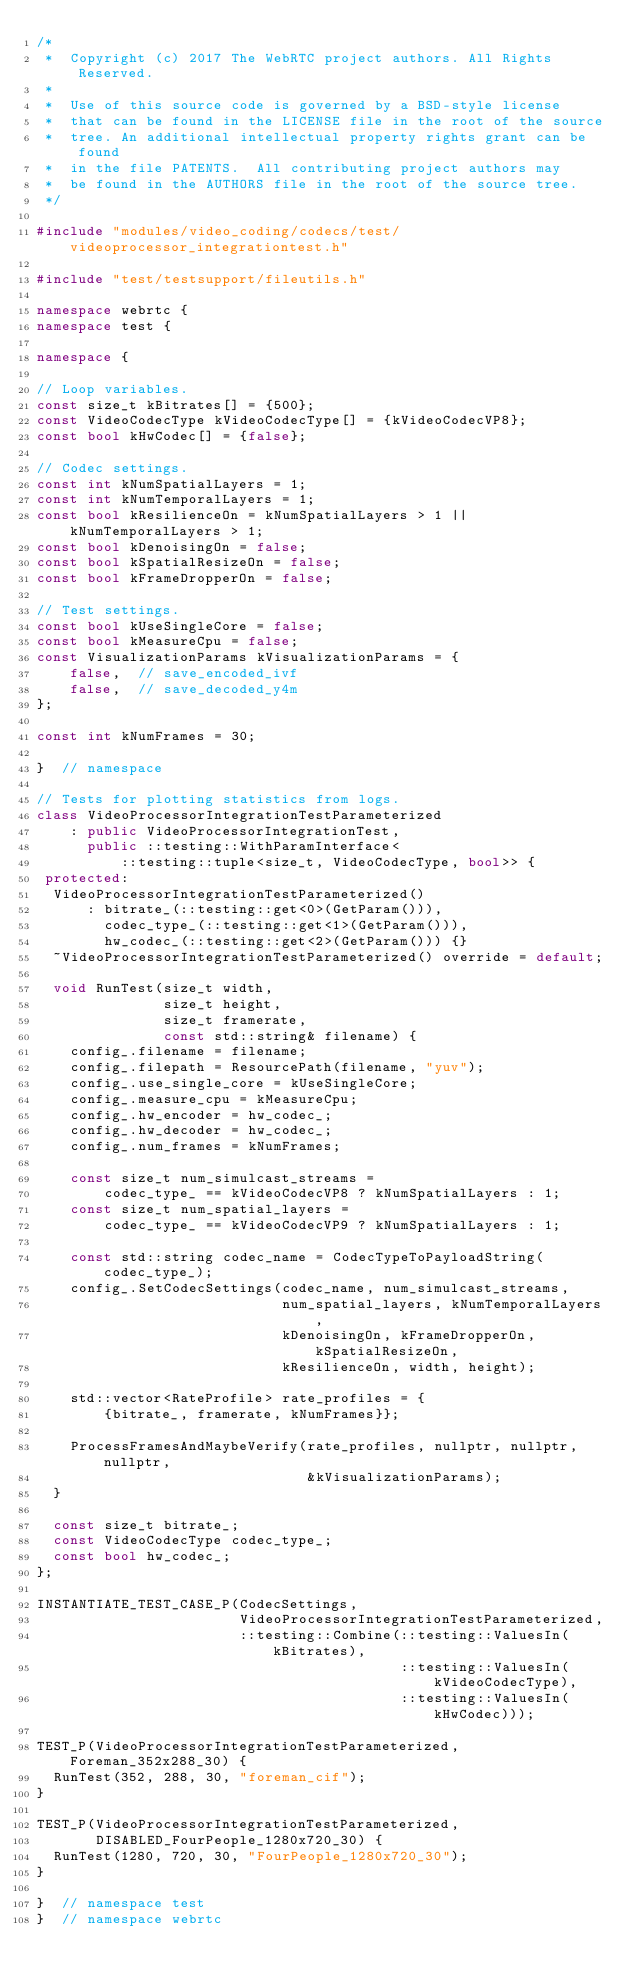<code> <loc_0><loc_0><loc_500><loc_500><_C++_>/*
 *  Copyright (c) 2017 The WebRTC project authors. All Rights Reserved.
 *
 *  Use of this source code is governed by a BSD-style license
 *  that can be found in the LICENSE file in the root of the source
 *  tree. An additional intellectual property rights grant can be found
 *  in the file PATENTS.  All contributing project authors may
 *  be found in the AUTHORS file in the root of the source tree.
 */

#include "modules/video_coding/codecs/test/videoprocessor_integrationtest.h"

#include "test/testsupport/fileutils.h"

namespace webrtc {
namespace test {

namespace {

// Loop variables.
const size_t kBitrates[] = {500};
const VideoCodecType kVideoCodecType[] = {kVideoCodecVP8};
const bool kHwCodec[] = {false};

// Codec settings.
const int kNumSpatialLayers = 1;
const int kNumTemporalLayers = 1;
const bool kResilienceOn = kNumSpatialLayers > 1 || kNumTemporalLayers > 1;
const bool kDenoisingOn = false;
const bool kSpatialResizeOn = false;
const bool kFrameDropperOn = false;

// Test settings.
const bool kUseSingleCore = false;
const bool kMeasureCpu = false;
const VisualizationParams kVisualizationParams = {
    false,  // save_encoded_ivf
    false,  // save_decoded_y4m
};

const int kNumFrames = 30;

}  // namespace

// Tests for plotting statistics from logs.
class VideoProcessorIntegrationTestParameterized
    : public VideoProcessorIntegrationTest,
      public ::testing::WithParamInterface<
          ::testing::tuple<size_t, VideoCodecType, bool>> {
 protected:
  VideoProcessorIntegrationTestParameterized()
      : bitrate_(::testing::get<0>(GetParam())),
        codec_type_(::testing::get<1>(GetParam())),
        hw_codec_(::testing::get<2>(GetParam())) {}
  ~VideoProcessorIntegrationTestParameterized() override = default;

  void RunTest(size_t width,
               size_t height,
               size_t framerate,
               const std::string& filename) {
    config_.filename = filename;
    config_.filepath = ResourcePath(filename, "yuv");
    config_.use_single_core = kUseSingleCore;
    config_.measure_cpu = kMeasureCpu;
    config_.hw_encoder = hw_codec_;
    config_.hw_decoder = hw_codec_;
    config_.num_frames = kNumFrames;

    const size_t num_simulcast_streams =
        codec_type_ == kVideoCodecVP8 ? kNumSpatialLayers : 1;
    const size_t num_spatial_layers =
        codec_type_ == kVideoCodecVP9 ? kNumSpatialLayers : 1;

    const std::string codec_name = CodecTypeToPayloadString(codec_type_);
    config_.SetCodecSettings(codec_name, num_simulcast_streams,
                             num_spatial_layers, kNumTemporalLayers,
                             kDenoisingOn, kFrameDropperOn, kSpatialResizeOn,
                             kResilienceOn, width, height);

    std::vector<RateProfile> rate_profiles = {
        {bitrate_, framerate, kNumFrames}};

    ProcessFramesAndMaybeVerify(rate_profiles, nullptr, nullptr, nullptr,
                                &kVisualizationParams);
  }

  const size_t bitrate_;
  const VideoCodecType codec_type_;
  const bool hw_codec_;
};

INSTANTIATE_TEST_CASE_P(CodecSettings,
                        VideoProcessorIntegrationTestParameterized,
                        ::testing::Combine(::testing::ValuesIn(kBitrates),
                                           ::testing::ValuesIn(kVideoCodecType),
                                           ::testing::ValuesIn(kHwCodec)));

TEST_P(VideoProcessorIntegrationTestParameterized, Foreman_352x288_30) {
  RunTest(352, 288, 30, "foreman_cif");
}

TEST_P(VideoProcessorIntegrationTestParameterized,
       DISABLED_FourPeople_1280x720_30) {
  RunTest(1280, 720, 30, "FourPeople_1280x720_30");
}

}  // namespace test
}  // namespace webrtc
</code> 